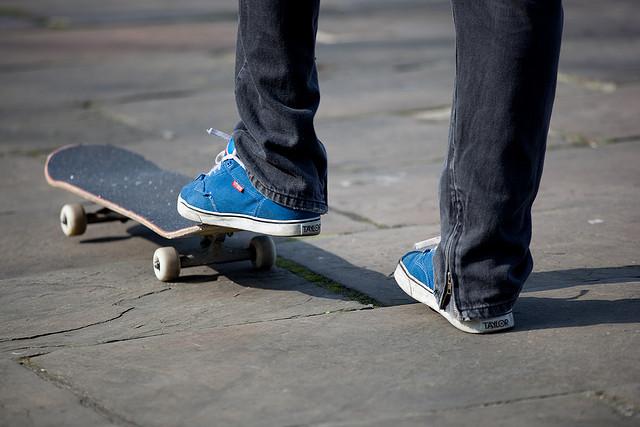How many feet are on the skateboard?
Short answer required. 1. Is the person pushing the skateboard with one leg?
Be succinct. Yes. Is this skateboard typically used on ramps?
Concise answer only. Yes. Is a shadow cast?
Write a very short answer. Yes. 